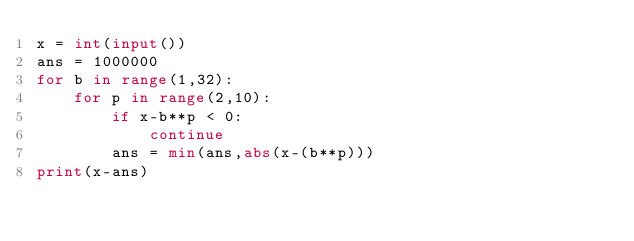Convert code to text. <code><loc_0><loc_0><loc_500><loc_500><_Python_>x = int(input())
ans = 1000000
for b in range(1,32):
    for p in range(2,10):
        if x-b**p < 0:
            continue
        ans = min(ans,abs(x-(b**p)))
print(x-ans)
</code> 